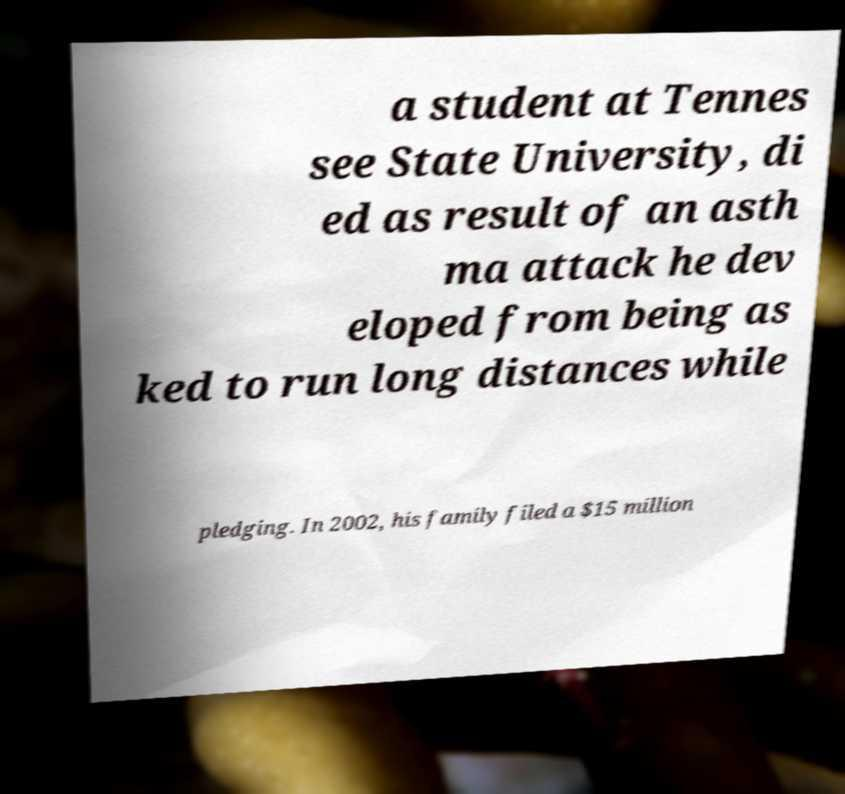Can you read and provide the text displayed in the image?This photo seems to have some interesting text. Can you extract and type it out for me? a student at Tennes see State University, di ed as result of an asth ma attack he dev eloped from being as ked to run long distances while pledging. In 2002, his family filed a $15 million 